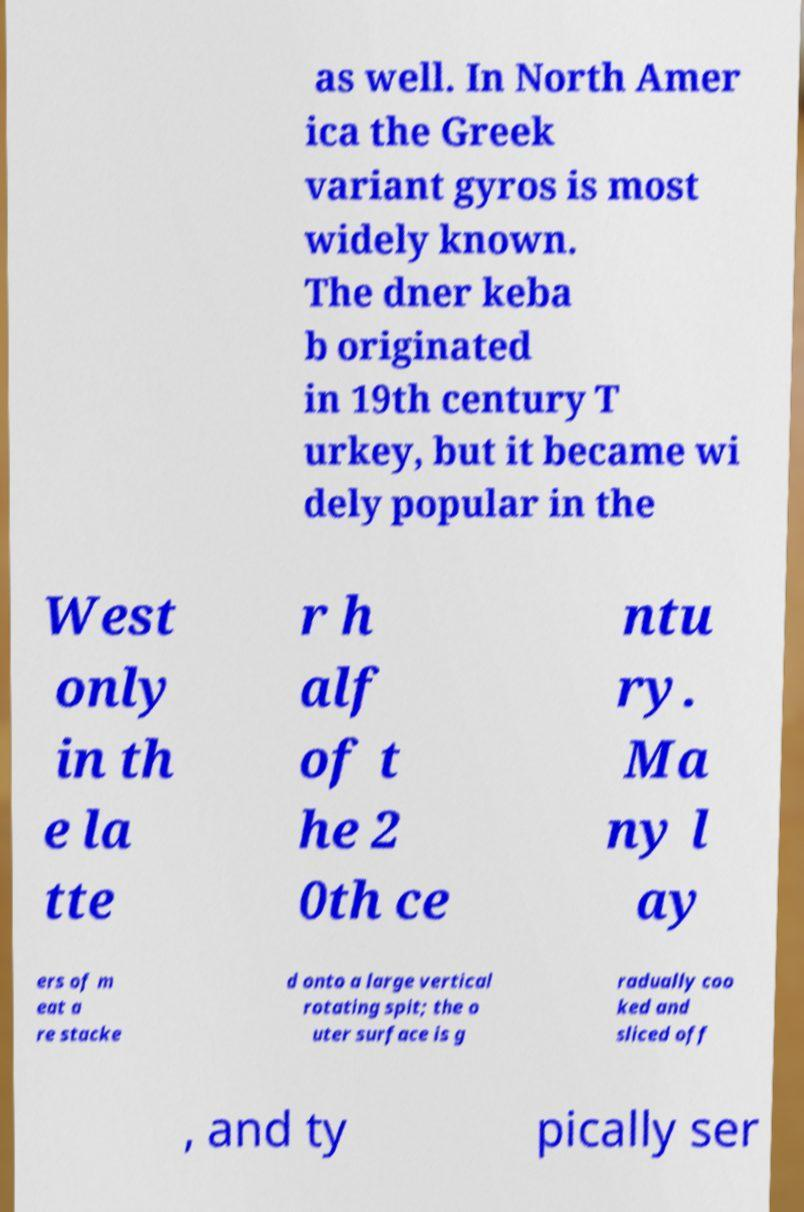Please identify and transcribe the text found in this image. as well. In North Amer ica the Greek variant gyros is most widely known. The dner keba b originated in 19th century T urkey, but it became wi dely popular in the West only in th e la tte r h alf of t he 2 0th ce ntu ry. Ma ny l ay ers of m eat a re stacke d onto a large vertical rotating spit; the o uter surface is g radually coo ked and sliced off , and ty pically ser 